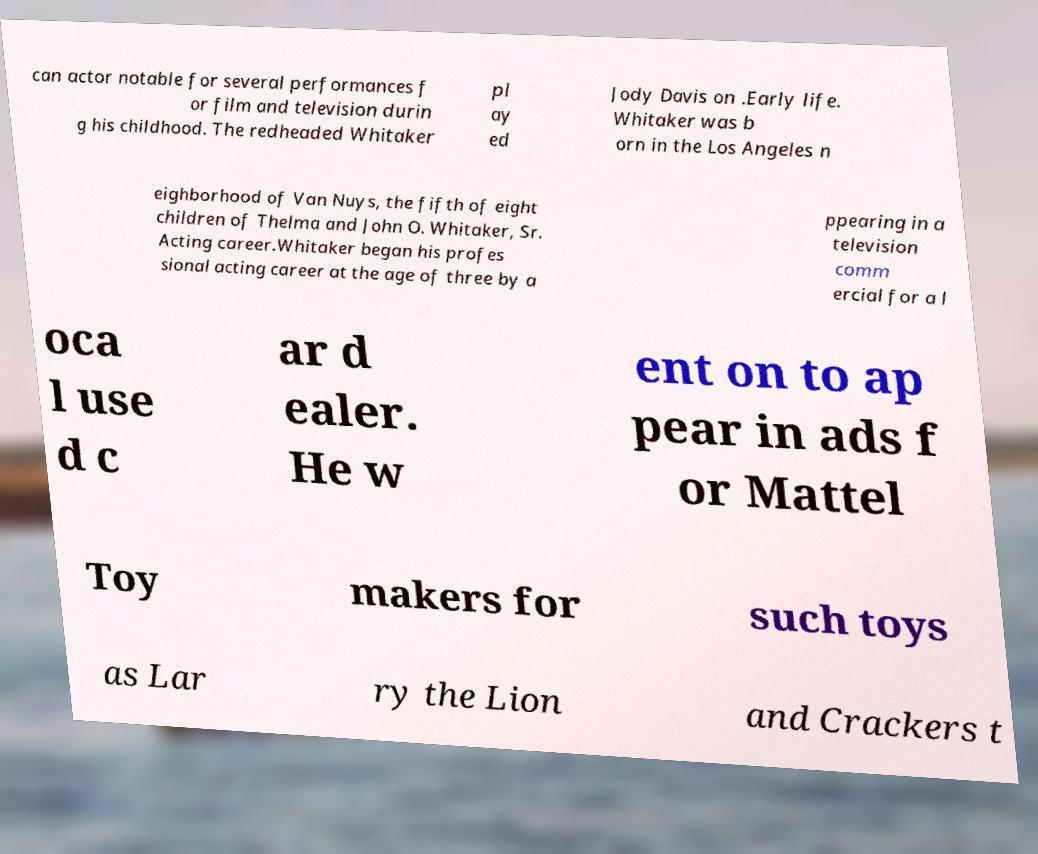What messages or text are displayed in this image? I need them in a readable, typed format. can actor notable for several performances f or film and television durin g his childhood. The redheaded Whitaker pl ay ed Jody Davis on .Early life. Whitaker was b orn in the Los Angeles n eighborhood of Van Nuys, the fifth of eight children of Thelma and John O. Whitaker, Sr. Acting career.Whitaker began his profes sional acting career at the age of three by a ppearing in a television comm ercial for a l oca l use d c ar d ealer. He w ent on to ap pear in ads f or Mattel Toy makers for such toys as Lar ry the Lion and Crackers t 